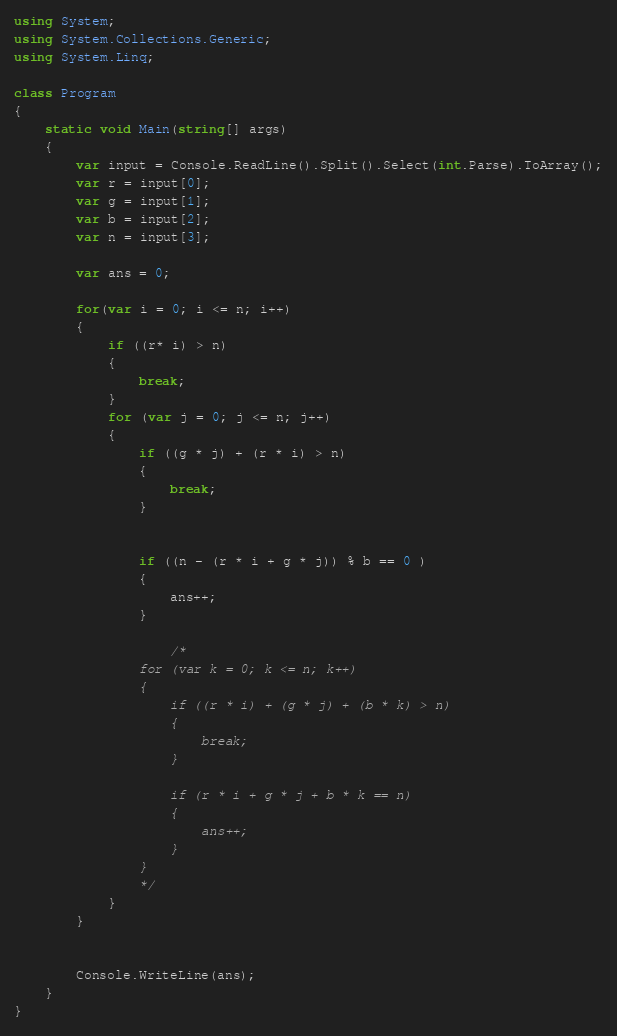Convert code to text. <code><loc_0><loc_0><loc_500><loc_500><_C#_>using System;
using System.Collections.Generic;
using System.Linq;

class Program
{
    static void Main(string[] args)
    {
        var input = Console.ReadLine().Split().Select(int.Parse).ToArray();
        var r = input[0];
        var g = input[1];
        var b = input[2];
        var n = input[3];

        var ans = 0;

        for(var i = 0; i <= n; i++)
        {
            if ((r* i) > n)
            {
                break;
            }
            for (var j = 0; j <= n; j++)
            {
                if ((g * j) + (r * i) > n)
                {
                    break;
                }


                if ((n - (r * i + g * j)) % b == 0 )
                {
                    ans++;
                }

                    /*
                for (var k = 0; k <= n; k++)
                {
                    if ((r * i) + (g * j) + (b * k) > n)
                    {
                        break;
                    }

                    if (r * i + g * j + b * k == n)
                    {
                        ans++;
                    } 
                }
                */
            }
        }


        Console.WriteLine(ans);
    }
}
</code> 